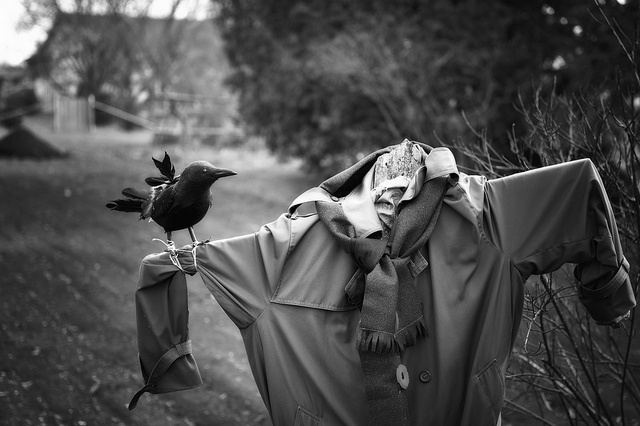Describe the objects in this image and their specific colors. I can see a bird in white, black, gray, darkgray, and lightgray tones in this image. 